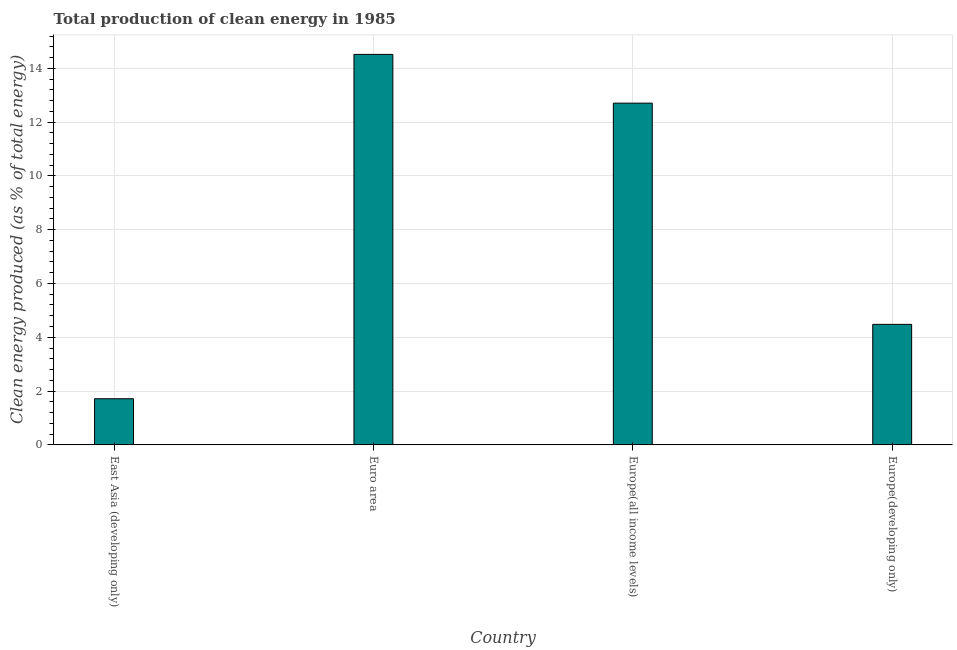Does the graph contain any zero values?
Make the answer very short. No. What is the title of the graph?
Your answer should be very brief. Total production of clean energy in 1985. What is the label or title of the X-axis?
Your response must be concise. Country. What is the label or title of the Y-axis?
Offer a terse response. Clean energy produced (as % of total energy). What is the production of clean energy in East Asia (developing only)?
Make the answer very short. 1.71. Across all countries, what is the maximum production of clean energy?
Ensure brevity in your answer.  14.52. Across all countries, what is the minimum production of clean energy?
Provide a succinct answer. 1.71. In which country was the production of clean energy minimum?
Give a very brief answer. East Asia (developing only). What is the sum of the production of clean energy?
Your response must be concise. 33.42. What is the difference between the production of clean energy in Euro area and Europe(all income levels)?
Give a very brief answer. 1.81. What is the average production of clean energy per country?
Your response must be concise. 8.36. What is the median production of clean energy?
Provide a short and direct response. 8.59. In how many countries, is the production of clean energy greater than 6.4 %?
Provide a succinct answer. 2. What is the ratio of the production of clean energy in East Asia (developing only) to that in Europe(all income levels)?
Offer a very short reply. 0.14. Is the production of clean energy in Europe(all income levels) less than that in Europe(developing only)?
Give a very brief answer. No. Is the difference between the production of clean energy in East Asia (developing only) and Europe(developing only) greater than the difference between any two countries?
Your answer should be compact. No. What is the difference between the highest and the second highest production of clean energy?
Provide a succinct answer. 1.81. Is the sum of the production of clean energy in Euro area and Europe(developing only) greater than the maximum production of clean energy across all countries?
Make the answer very short. Yes. What is the difference between the highest and the lowest production of clean energy?
Your response must be concise. 12.81. How many bars are there?
Provide a short and direct response. 4. How many countries are there in the graph?
Keep it short and to the point. 4. Are the values on the major ticks of Y-axis written in scientific E-notation?
Make the answer very short. No. What is the Clean energy produced (as % of total energy) of East Asia (developing only)?
Give a very brief answer. 1.71. What is the Clean energy produced (as % of total energy) in Euro area?
Your answer should be very brief. 14.52. What is the Clean energy produced (as % of total energy) of Europe(all income levels)?
Make the answer very short. 12.71. What is the Clean energy produced (as % of total energy) in Europe(developing only)?
Your answer should be very brief. 4.48. What is the difference between the Clean energy produced (as % of total energy) in East Asia (developing only) and Euro area?
Keep it short and to the point. -12.81. What is the difference between the Clean energy produced (as % of total energy) in East Asia (developing only) and Europe(all income levels)?
Provide a succinct answer. -10.99. What is the difference between the Clean energy produced (as % of total energy) in East Asia (developing only) and Europe(developing only)?
Provide a short and direct response. -2.77. What is the difference between the Clean energy produced (as % of total energy) in Euro area and Europe(all income levels)?
Offer a terse response. 1.81. What is the difference between the Clean energy produced (as % of total energy) in Euro area and Europe(developing only)?
Give a very brief answer. 10.04. What is the difference between the Clean energy produced (as % of total energy) in Europe(all income levels) and Europe(developing only)?
Your answer should be compact. 8.23. What is the ratio of the Clean energy produced (as % of total energy) in East Asia (developing only) to that in Euro area?
Provide a short and direct response. 0.12. What is the ratio of the Clean energy produced (as % of total energy) in East Asia (developing only) to that in Europe(all income levels)?
Provide a short and direct response. 0.14. What is the ratio of the Clean energy produced (as % of total energy) in East Asia (developing only) to that in Europe(developing only)?
Keep it short and to the point. 0.38. What is the ratio of the Clean energy produced (as % of total energy) in Euro area to that in Europe(all income levels)?
Give a very brief answer. 1.14. What is the ratio of the Clean energy produced (as % of total energy) in Euro area to that in Europe(developing only)?
Your response must be concise. 3.24. What is the ratio of the Clean energy produced (as % of total energy) in Europe(all income levels) to that in Europe(developing only)?
Offer a very short reply. 2.84. 